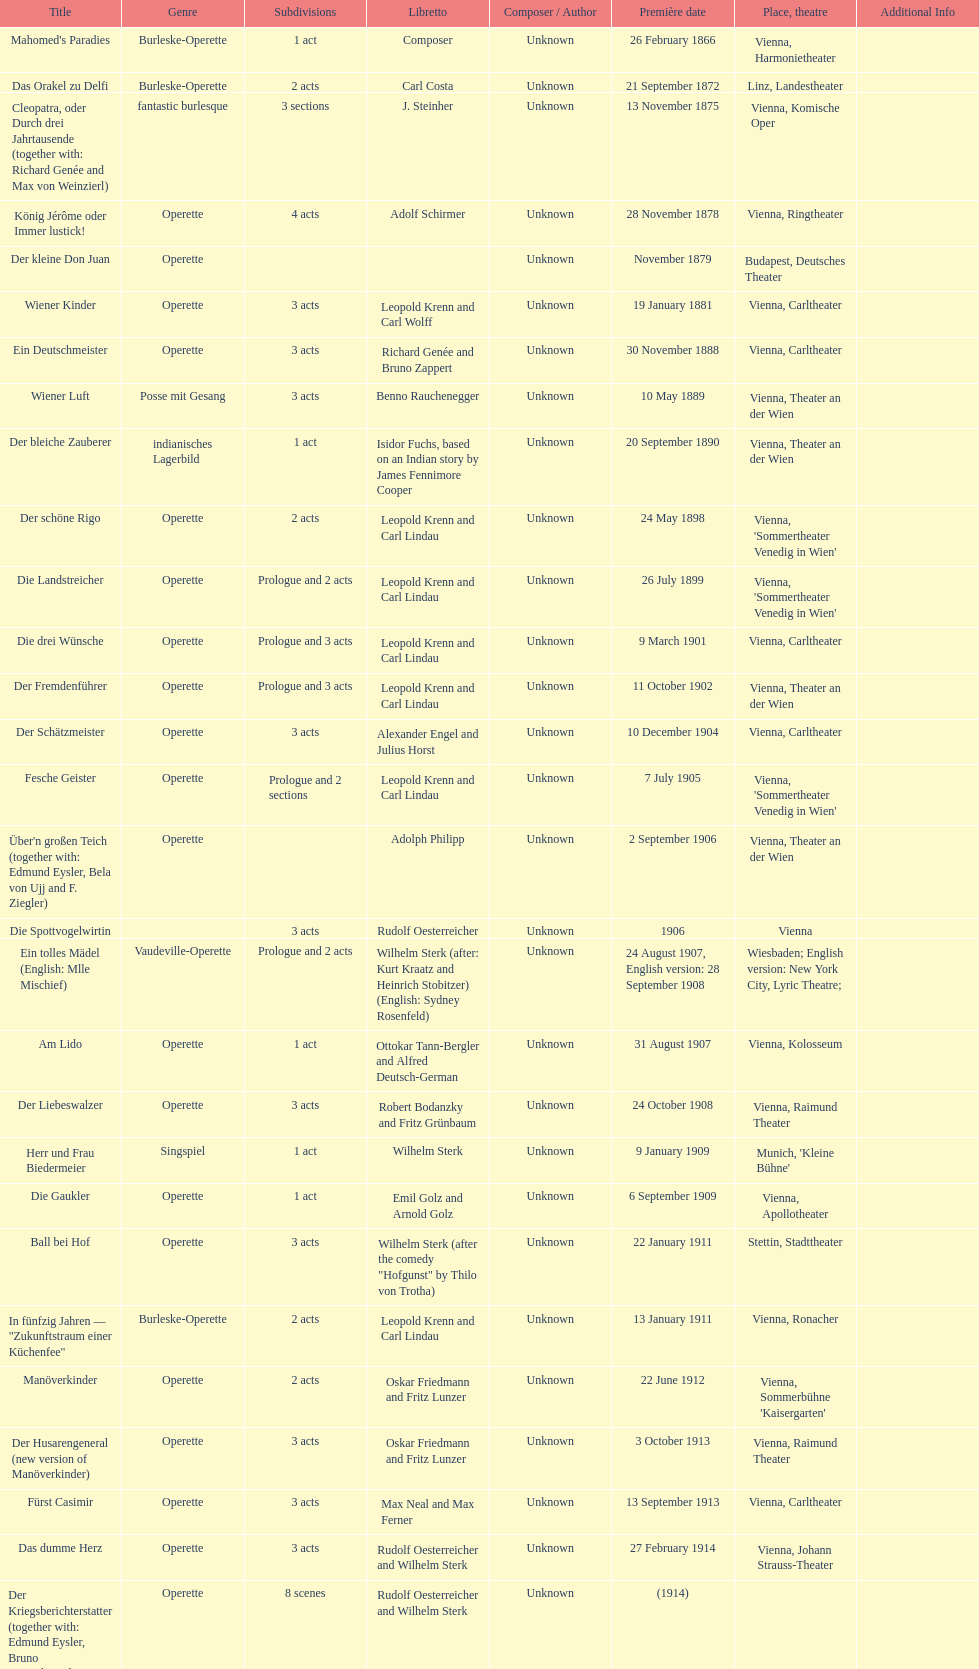Which genre is featured the most in this chart? Operette. 